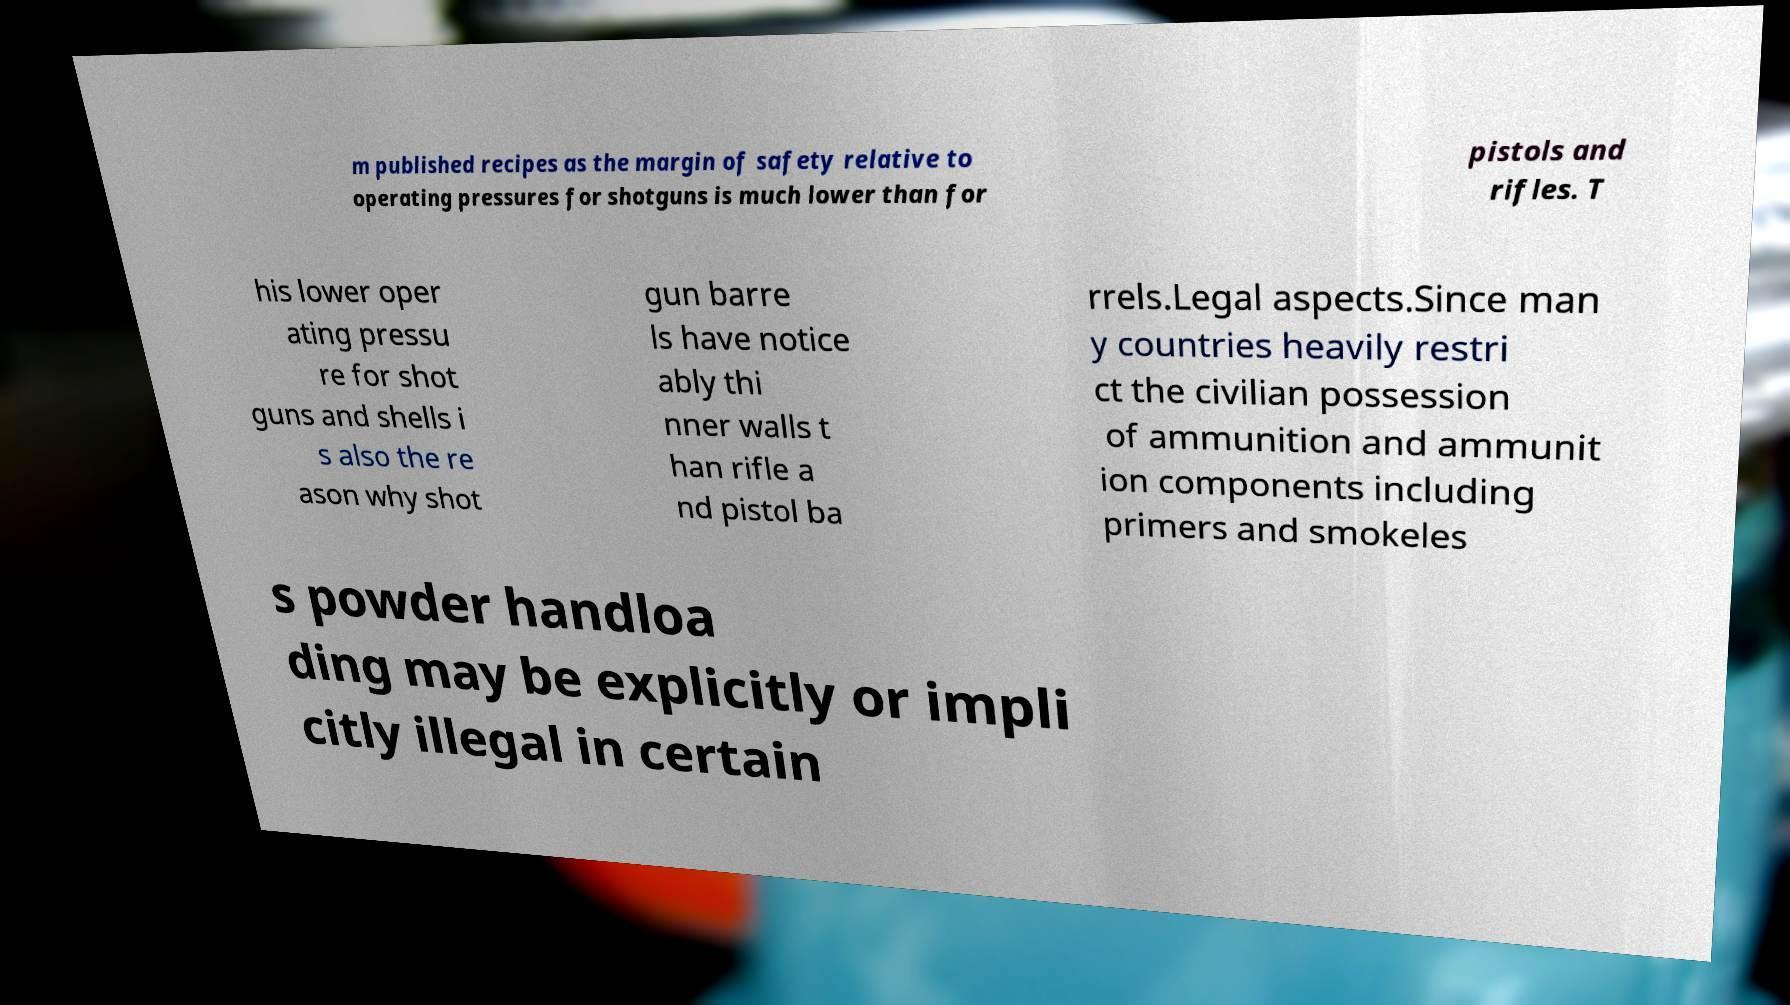Please read and relay the text visible in this image. What does it say? m published recipes as the margin of safety relative to operating pressures for shotguns is much lower than for pistols and rifles. T his lower oper ating pressu re for shot guns and shells i s also the re ason why shot gun barre ls have notice ably thi nner walls t han rifle a nd pistol ba rrels.Legal aspects.Since man y countries heavily restri ct the civilian possession of ammunition and ammunit ion components including primers and smokeles s powder handloa ding may be explicitly or impli citly illegal in certain 